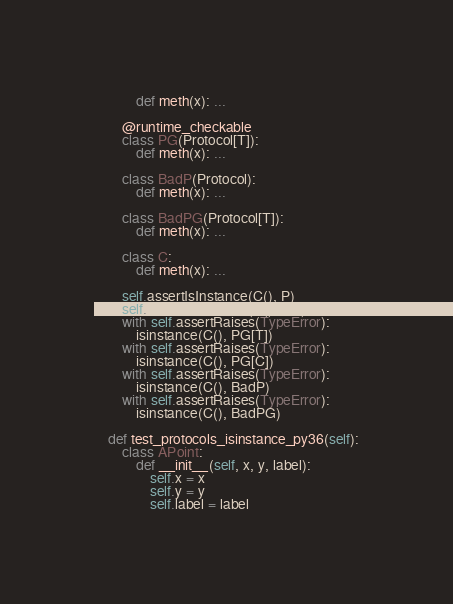Convert code to text. <code><loc_0><loc_0><loc_500><loc_500><_Python_>            def meth(x): ...

        @runtime_checkable
        class PG(Protocol[T]):
            def meth(x): ...

        class BadP(Protocol):
            def meth(x): ...

        class BadPG(Protocol[T]):
            def meth(x): ...

        class C:
            def meth(x): ...

        self.assertIsInstance(C(), P)
        self.assertIsInstance(C(), PG)
        with self.assertRaises(TypeError):
            isinstance(C(), PG[T])
        with self.assertRaises(TypeError):
            isinstance(C(), PG[C])
        with self.assertRaises(TypeError):
            isinstance(C(), BadP)
        with self.assertRaises(TypeError):
            isinstance(C(), BadPG)

    def test_protocols_isinstance_py36(self):
        class APoint:
            def __init__(self, x, y, label):
                self.x = x
                self.y = y
                self.label = label
</code> 